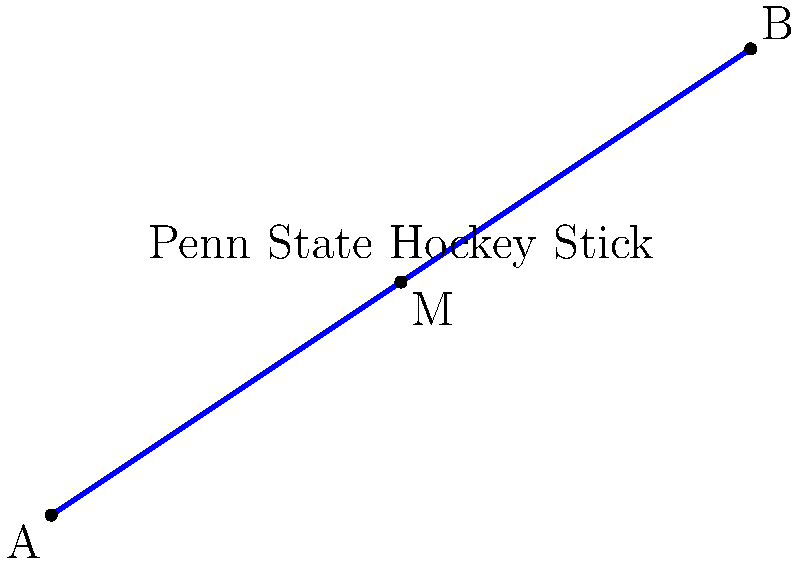A Penn State hockey stick is represented by a line segment from point A(0,0) to point B(6,4) on a coordinate plane. Find the coordinates of point M, which represents the midpoint of the hockey stick. To find the midpoint M of a line segment AB, we use the midpoint formula:

$$ M = \left(\frac{x_1 + x_2}{2}, \frac{y_1 + y_2}{2}\right) $$

Where $(x_1, y_1)$ are the coordinates of point A, and $(x_2, y_2)$ are the coordinates of point B.

Given:
- Point A: (0,0)
- Point B: (6,4)

Step 1: Calculate the x-coordinate of the midpoint:
$$ x_M = \frac{x_1 + x_2}{2} = \frac{0 + 6}{2} = \frac{6}{2} = 3 $$

Step 2: Calculate the y-coordinate of the midpoint:
$$ y_M = \frac{y_1 + y_2}{2} = \frac{0 + 4}{2} = \frac{4}{2} = 2 $$

Therefore, the coordinates of the midpoint M are (3,2).
Answer: (3,2) 